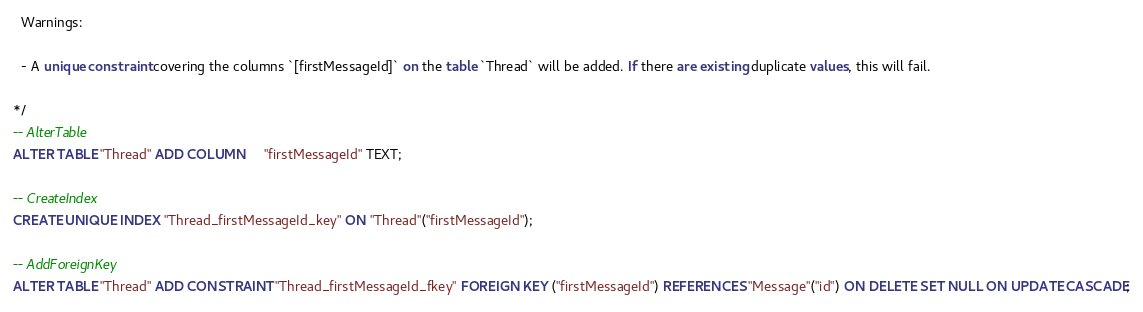<code> <loc_0><loc_0><loc_500><loc_500><_SQL_>  Warnings:

  - A unique constraint covering the columns `[firstMessageId]` on the table `Thread` will be added. If there are existing duplicate values, this will fail.

*/
-- AlterTable
ALTER TABLE "Thread" ADD COLUMN     "firstMessageId" TEXT;

-- CreateIndex
CREATE UNIQUE INDEX "Thread_firstMessageId_key" ON "Thread"("firstMessageId");

-- AddForeignKey
ALTER TABLE "Thread" ADD CONSTRAINT "Thread_firstMessageId_fkey" FOREIGN KEY ("firstMessageId") REFERENCES "Message"("id") ON DELETE SET NULL ON UPDATE CASCADE;
</code> 